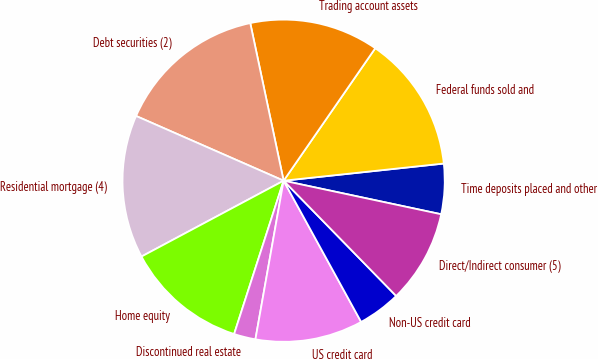Convert chart. <chart><loc_0><loc_0><loc_500><loc_500><pie_chart><fcel>Time deposits placed and other<fcel>Federal funds sold and<fcel>Trading account assets<fcel>Debt securities (2)<fcel>Residential mortgage (4)<fcel>Home equity<fcel>Discontinued real estate<fcel>US credit card<fcel>Non-US credit card<fcel>Direct/Indirect consumer (5)<nl><fcel>5.04%<fcel>13.67%<fcel>12.95%<fcel>15.1%<fcel>14.38%<fcel>12.23%<fcel>2.17%<fcel>10.79%<fcel>4.32%<fcel>9.35%<nl></chart> 